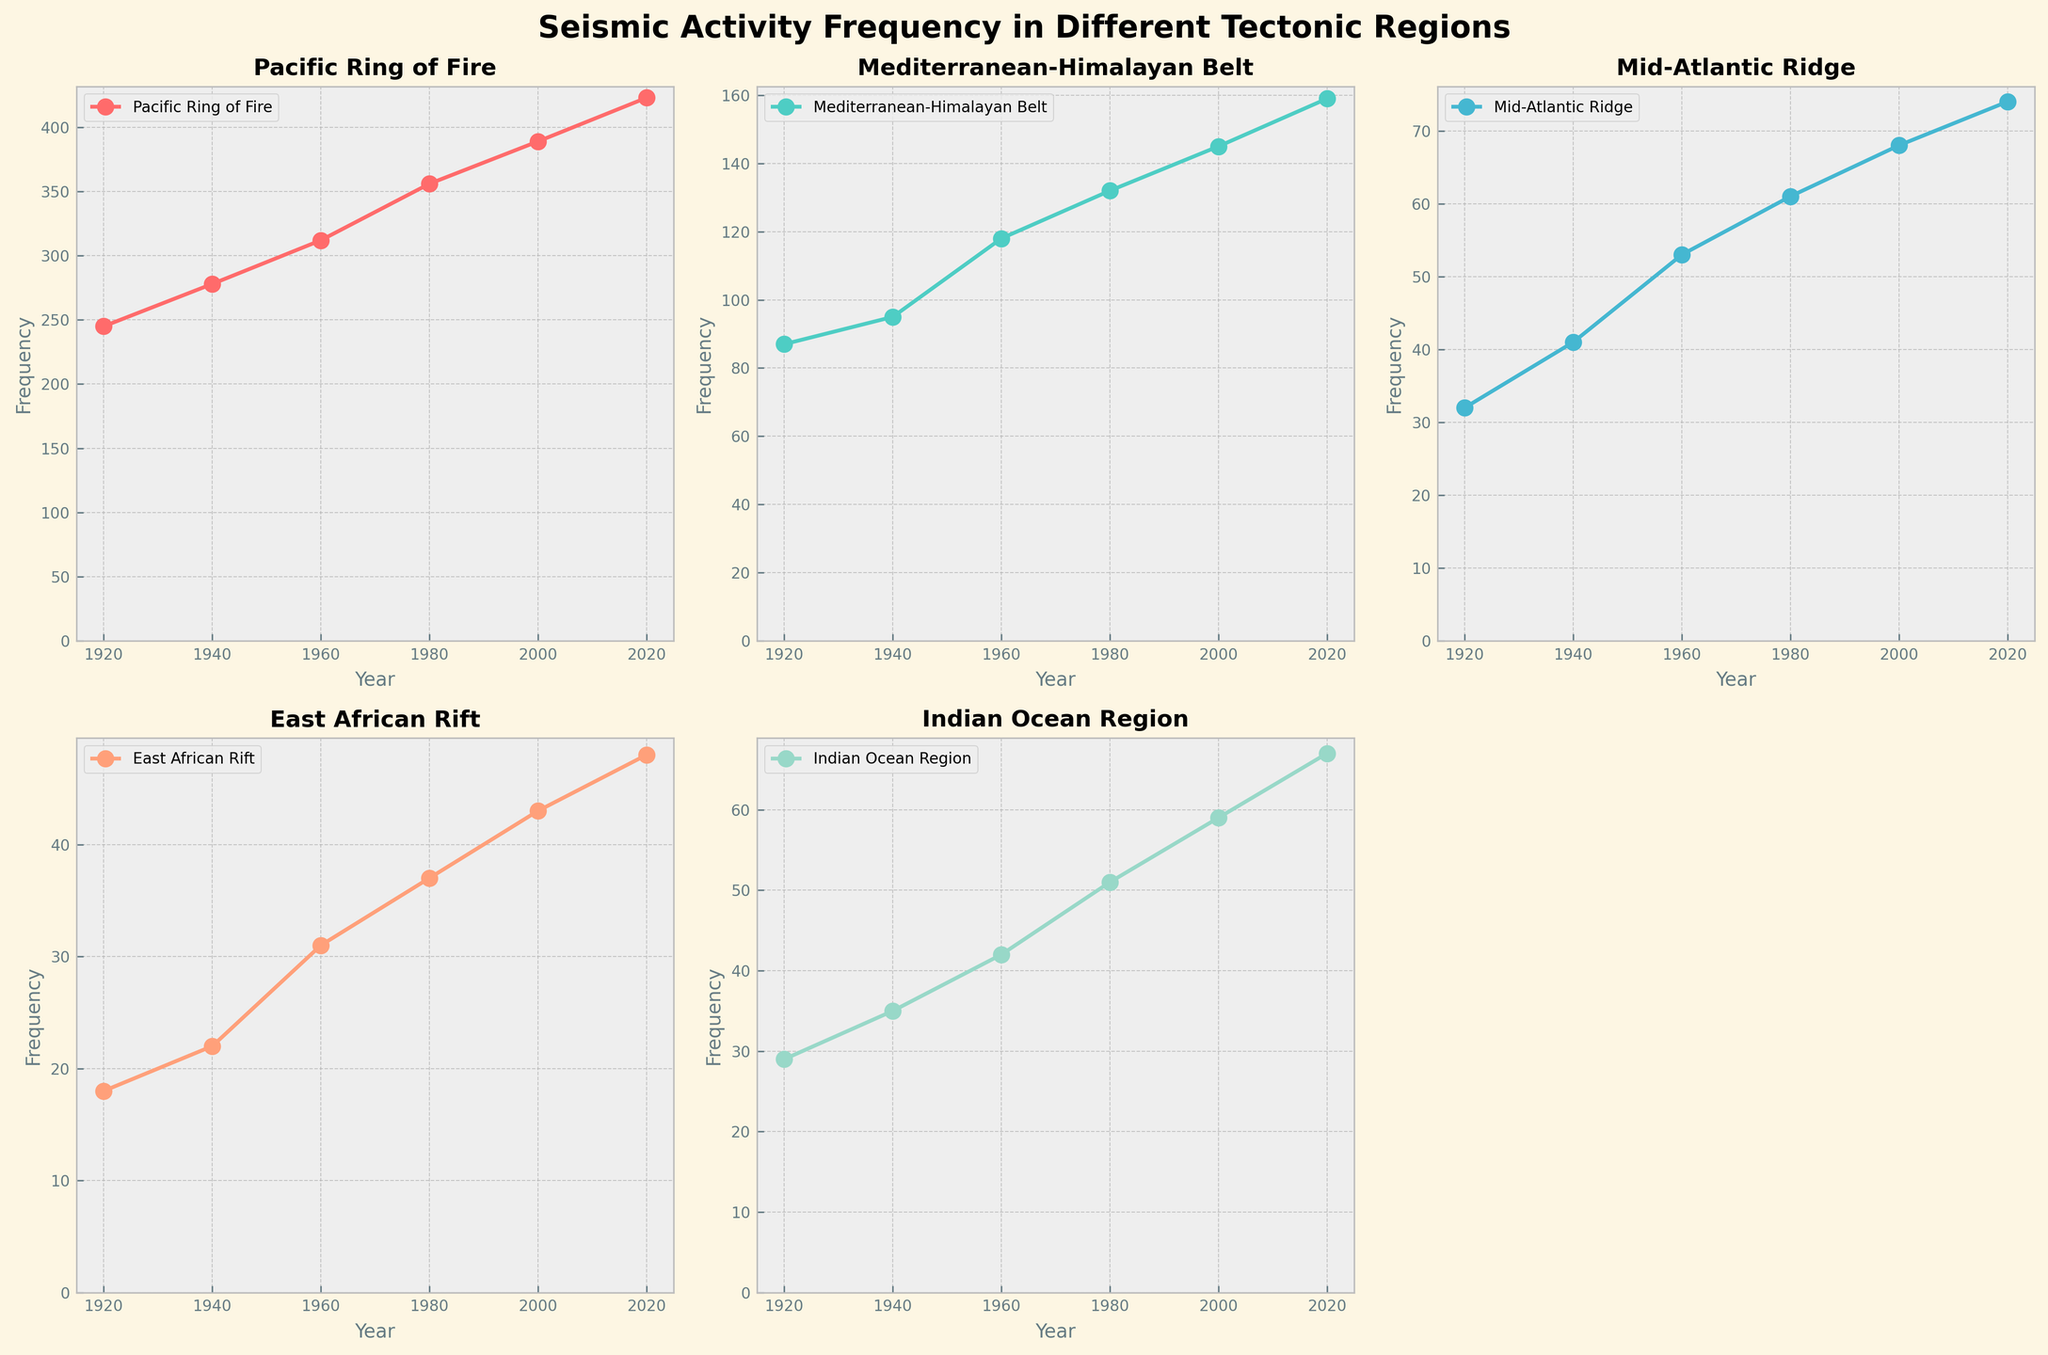What is the title of the overall figure? The title of the overall figure is clearly stated at the top of the plot grid. The title reads "Seismic Activity Frequency in Different Tectonic Regions."
Answer: Seismic Activity Frequency in Different Tectonic Regions How many subplots are there in the grid, and which subplot is intentionally left blank? The subplot grid is 2 rows by 3 columns, making 6 subplots in total. One subplot in the bottom right corner is left blank, making the actual number of plots 5.
Answer: 6 subplots, bottom-right is blank Which region had the highest seismic activity frequency in the year 2020? By looking at all the lines in the year 2020 along the x-axis, the Pacific Ring of Fire has the highest frequency compared to the other regions.
Answer: Pacific Ring of Fire What is the difference in seismic activity frequency between the Mediterranean-Himalayan Belt and the Mid-Atlantic Ridge in the year 2020? First, find the frequency for both regions in 2020 (Mediterranean-Himalayan Belt: 159, Mid-Atlantic Ridge: 74). Then, subtract the Mid-Atlantic Ridge frequency from the Mediterranean-Himalayan Belt frequency (159 - 74).
Answer: 85 Between which consecutive years did the East African Rift see the largest increase in seismic activity frequency? The differences in frequency are calculated between consecutive years. The largest difference for East African Rift is observed between 1960 and 1980 (37 - 31 = 6).
Answer: 1960 and 1980 On which subplot do we find the data for the Indian Ocean Region? Looking at the subplot grid, the Indian Ocean Region is found in the bottom center position. It is the second plot in the second row.
Answer: Bottom center What is the average seismic activity frequency for the Mid-Atlantic Ridge over the recorded years? Sum the frequencies for all years (32, 41, 53, 61, 68, 74) and divide by the number of years (6). (32 + 41 + 53 + 61 + 68 + 74) / 6 = 329 / 6 = 54.83
Answer: 54.83 Which tectonic region shows a consistent increase in seismic activity frequency across all recorded years? Observing the trend lines for each subplot, the Pacific Ring of Fire shows a consistent increase in seismic frequency every year without any year-on-year decrease.
Answer: Pacific Ring of Fire 